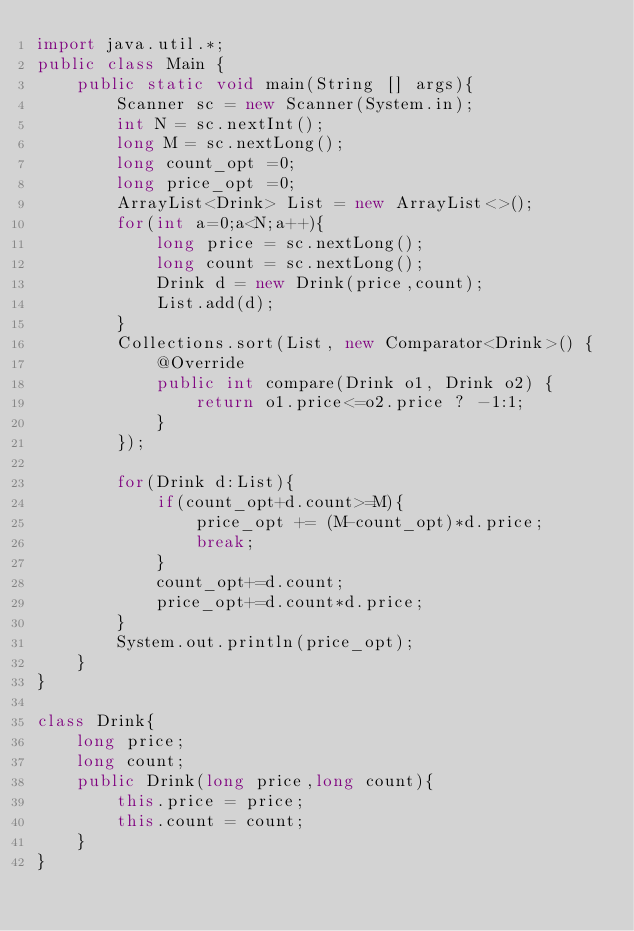Convert code to text. <code><loc_0><loc_0><loc_500><loc_500><_Java_>import java.util.*;
public class Main {
    public static void main(String [] args){
        Scanner sc = new Scanner(System.in);
        int N = sc.nextInt();
        long M = sc.nextLong();
        long count_opt =0;
        long price_opt =0;
        ArrayList<Drink> List = new ArrayList<>();
        for(int a=0;a<N;a++){
            long price = sc.nextLong();
            long count = sc.nextLong();
            Drink d = new Drink(price,count);
            List.add(d);
        }
        Collections.sort(List, new Comparator<Drink>() {
            @Override
            public int compare(Drink o1, Drink o2) {
                return o1.price<=o2.price ? -1:1;
            }
        });

        for(Drink d:List){
            if(count_opt+d.count>=M){
                price_opt += (M-count_opt)*d.price;
                break;
            }
            count_opt+=d.count;
            price_opt+=d.count*d.price;
        }
        System.out.println(price_opt);
    }
}

class Drink{
    long price;
    long count;
    public Drink(long price,long count){
        this.price = price;
        this.count = count;
    }
}</code> 